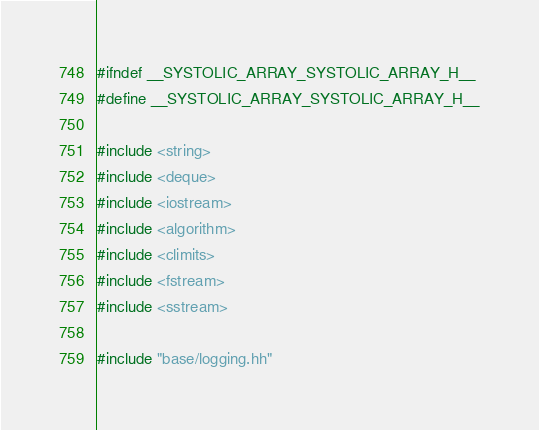<code> <loc_0><loc_0><loc_500><loc_500><_C_>#ifndef __SYSTOLIC_ARRAY_SYSTOLIC_ARRAY_H__
#define __SYSTOLIC_ARRAY_SYSTOLIC_ARRAY_H__

#include <string>
#include <deque>
#include <iostream>
#include <algorithm>
#include <climits>
#include <fstream>
#include <sstream>

#include "base/logging.hh"</code> 